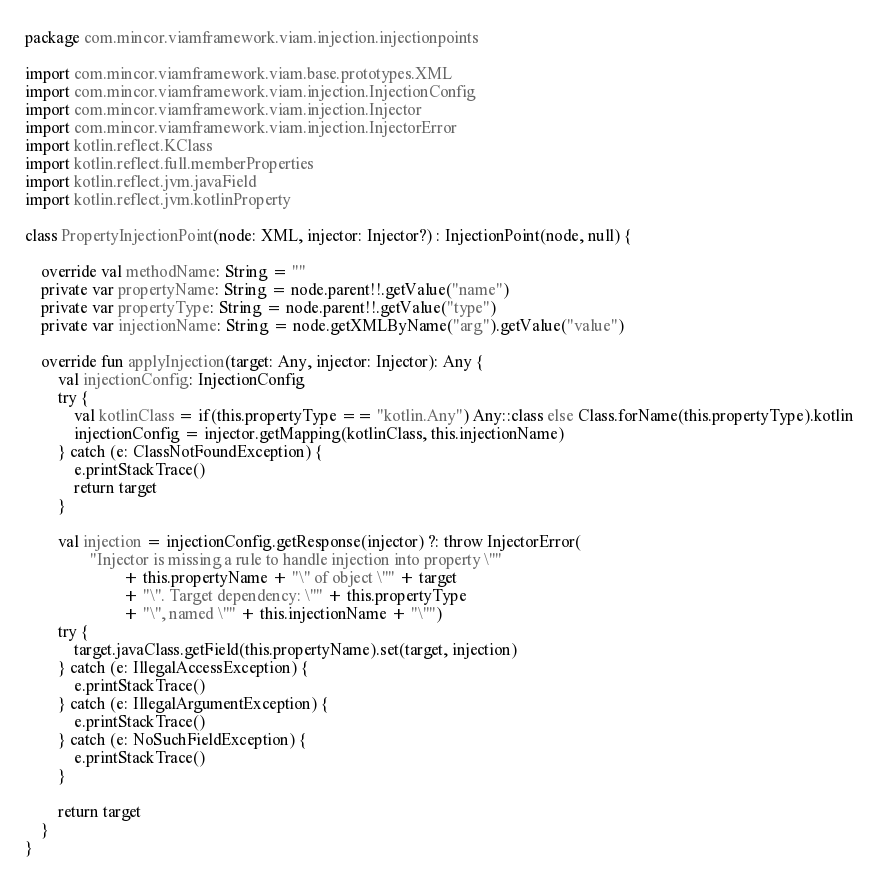<code> <loc_0><loc_0><loc_500><loc_500><_Kotlin_>package com.mincor.viamframework.viam.injection.injectionpoints

import com.mincor.viamframework.viam.base.prototypes.XML
import com.mincor.viamframework.viam.injection.InjectionConfig
import com.mincor.viamframework.viam.injection.Injector
import com.mincor.viamframework.viam.injection.InjectorError
import kotlin.reflect.KClass
import kotlin.reflect.full.memberProperties
import kotlin.reflect.jvm.javaField
import kotlin.reflect.jvm.kotlinProperty

class PropertyInjectionPoint(node: XML, injector: Injector?) : InjectionPoint(node, null) {

    override val methodName: String = ""
    private var propertyName: String = node.parent!!.getValue("name")
    private var propertyType: String = node.parent!!.getValue("type")
    private var injectionName: String = node.getXMLByName("arg").getValue("value")

    override fun applyInjection(target: Any, injector: Injector): Any {
        val injectionConfig: InjectionConfig
        try {
            val kotlinClass = if(this.propertyType == "kotlin.Any") Any::class else Class.forName(this.propertyType).kotlin
            injectionConfig = injector.getMapping(kotlinClass, this.injectionName)
        } catch (e: ClassNotFoundException) {
            e.printStackTrace()
            return target
        }

        val injection = injectionConfig.getResponse(injector) ?: throw InjectorError(
                "Injector is missing a rule to handle injection into property \""
                        + this.propertyName + "\" of object \"" + target
                        + "\". Target dependency: \"" + this.propertyType
                        + "\", named \"" + this.injectionName + "\"")
        try {
            target.javaClass.getField(this.propertyName).set(target, injection)
        } catch (e: IllegalAccessException) {
            e.printStackTrace()
        } catch (e: IllegalArgumentException) {
            e.printStackTrace()
        } catch (e: NoSuchFieldException) {
            e.printStackTrace()
        }

        return target
    }
}
</code> 